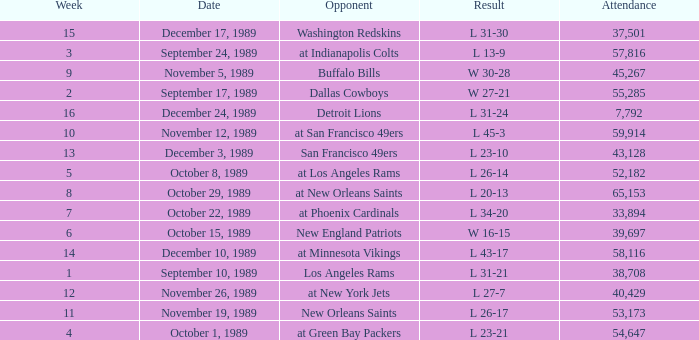The Detroit Lions were played against what week? 16.0. 